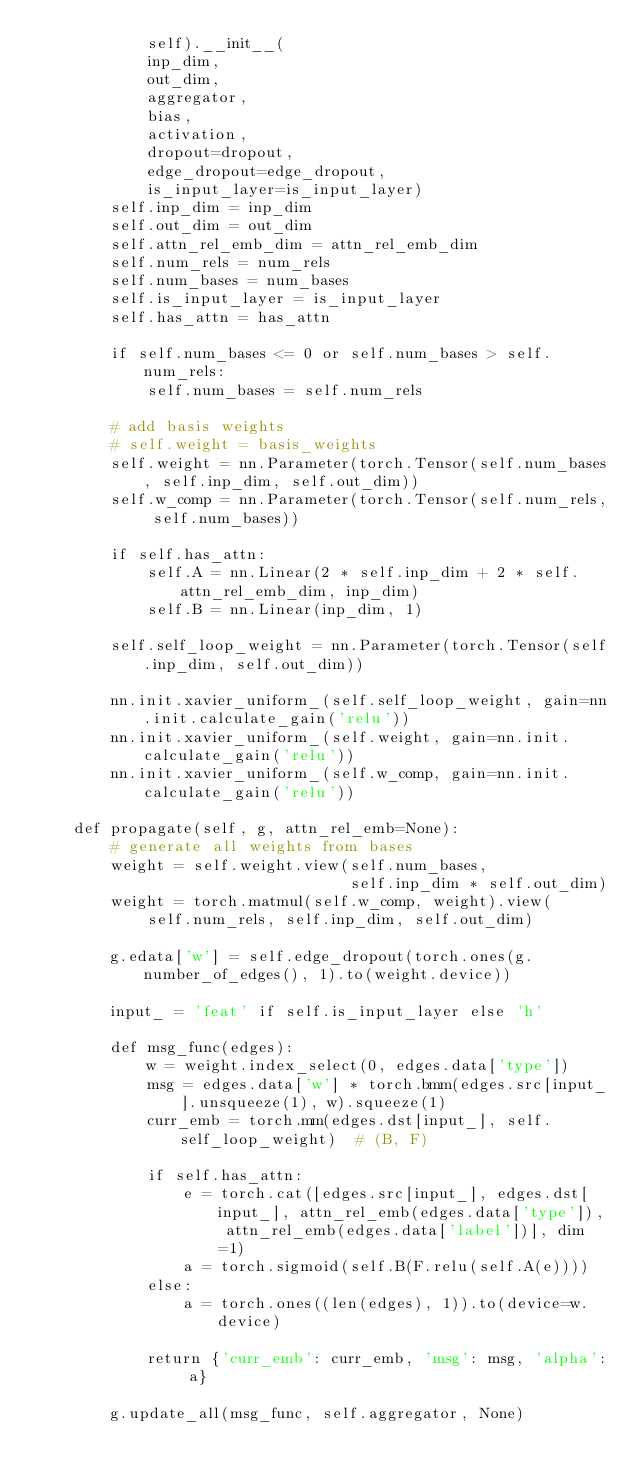Convert code to text. <code><loc_0><loc_0><loc_500><loc_500><_Python_>            self).__init__(
            inp_dim,
            out_dim,
            aggregator,
            bias,
            activation,
            dropout=dropout,
            edge_dropout=edge_dropout,
            is_input_layer=is_input_layer)
        self.inp_dim = inp_dim
        self.out_dim = out_dim
        self.attn_rel_emb_dim = attn_rel_emb_dim
        self.num_rels = num_rels
        self.num_bases = num_bases
        self.is_input_layer = is_input_layer
        self.has_attn = has_attn

        if self.num_bases <= 0 or self.num_bases > self.num_rels:
            self.num_bases = self.num_rels

        # add basis weights
        # self.weight = basis_weights
        self.weight = nn.Parameter(torch.Tensor(self.num_bases, self.inp_dim, self.out_dim))
        self.w_comp = nn.Parameter(torch.Tensor(self.num_rels, self.num_bases))

        if self.has_attn:
            self.A = nn.Linear(2 * self.inp_dim + 2 * self.attn_rel_emb_dim, inp_dim)
            self.B = nn.Linear(inp_dim, 1)

        self.self_loop_weight = nn.Parameter(torch.Tensor(self.inp_dim, self.out_dim))

        nn.init.xavier_uniform_(self.self_loop_weight, gain=nn.init.calculate_gain('relu'))
        nn.init.xavier_uniform_(self.weight, gain=nn.init.calculate_gain('relu'))
        nn.init.xavier_uniform_(self.w_comp, gain=nn.init.calculate_gain('relu'))

    def propagate(self, g, attn_rel_emb=None):
        # generate all weights from bases
        weight = self.weight.view(self.num_bases,
                                  self.inp_dim * self.out_dim)
        weight = torch.matmul(self.w_comp, weight).view(
            self.num_rels, self.inp_dim, self.out_dim)

        g.edata['w'] = self.edge_dropout(torch.ones(g.number_of_edges(), 1).to(weight.device))

        input_ = 'feat' if self.is_input_layer else 'h'

        def msg_func(edges):
            w = weight.index_select(0, edges.data['type'])
            msg = edges.data['w'] * torch.bmm(edges.src[input_].unsqueeze(1), w).squeeze(1)
            curr_emb = torch.mm(edges.dst[input_], self.self_loop_weight)  # (B, F)

            if self.has_attn:
                e = torch.cat([edges.src[input_], edges.dst[input_], attn_rel_emb(edges.data['type']), attn_rel_emb(edges.data['label'])], dim=1)
                a = torch.sigmoid(self.B(F.relu(self.A(e))))
            else:
                a = torch.ones((len(edges), 1)).to(device=w.device)

            return {'curr_emb': curr_emb, 'msg': msg, 'alpha': a}

        g.update_all(msg_func, self.aggregator, None)
</code> 